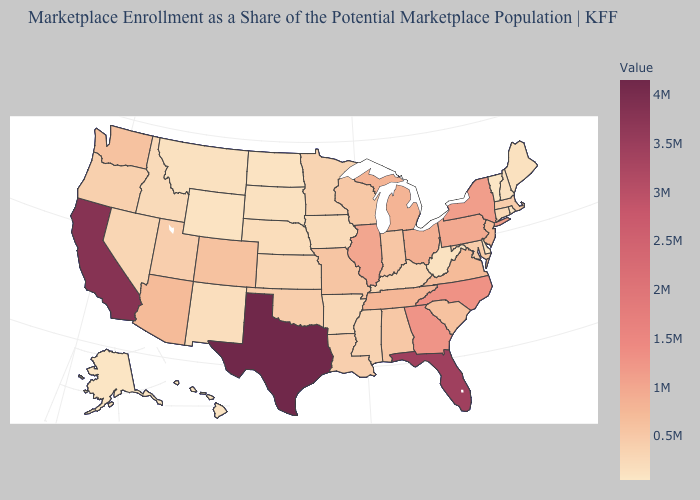Among the states that border Oklahoma , does Texas have the lowest value?
Quick response, please. No. Which states have the lowest value in the West?
Give a very brief answer. Alaska. Which states have the lowest value in the USA?
Answer briefly. Vermont. 